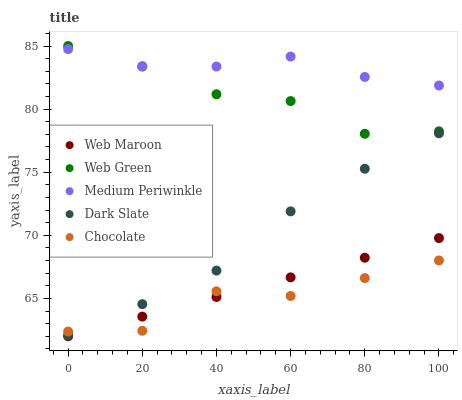Does Chocolate have the minimum area under the curve?
Answer yes or no. Yes. Does Medium Periwinkle have the maximum area under the curve?
Answer yes or no. Yes. Does Web Maroon have the minimum area under the curve?
Answer yes or no. No. Does Web Maroon have the maximum area under the curve?
Answer yes or no. No. Is Web Maroon the smoothest?
Answer yes or no. Yes. Is Chocolate the roughest?
Answer yes or no. Yes. Is Chocolate the smoothest?
Answer yes or no. No. Is Web Maroon the roughest?
Answer yes or no. No. Does Web Maroon have the lowest value?
Answer yes or no. Yes. Does Chocolate have the lowest value?
Answer yes or no. No. Does Web Green have the highest value?
Answer yes or no. Yes. Does Web Maroon have the highest value?
Answer yes or no. No. Is Web Maroon less than Medium Periwinkle?
Answer yes or no. Yes. Is Medium Periwinkle greater than Web Maroon?
Answer yes or no. Yes. Does Chocolate intersect Dark Slate?
Answer yes or no. Yes. Is Chocolate less than Dark Slate?
Answer yes or no. No. Is Chocolate greater than Dark Slate?
Answer yes or no. No. Does Web Maroon intersect Medium Periwinkle?
Answer yes or no. No. 